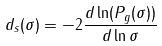<formula> <loc_0><loc_0><loc_500><loc_500>d _ { s } ( \sigma ) = - 2 \frac { d \ln ( P _ { g } ( \sigma ) ) } { d \ln \sigma }</formula> 